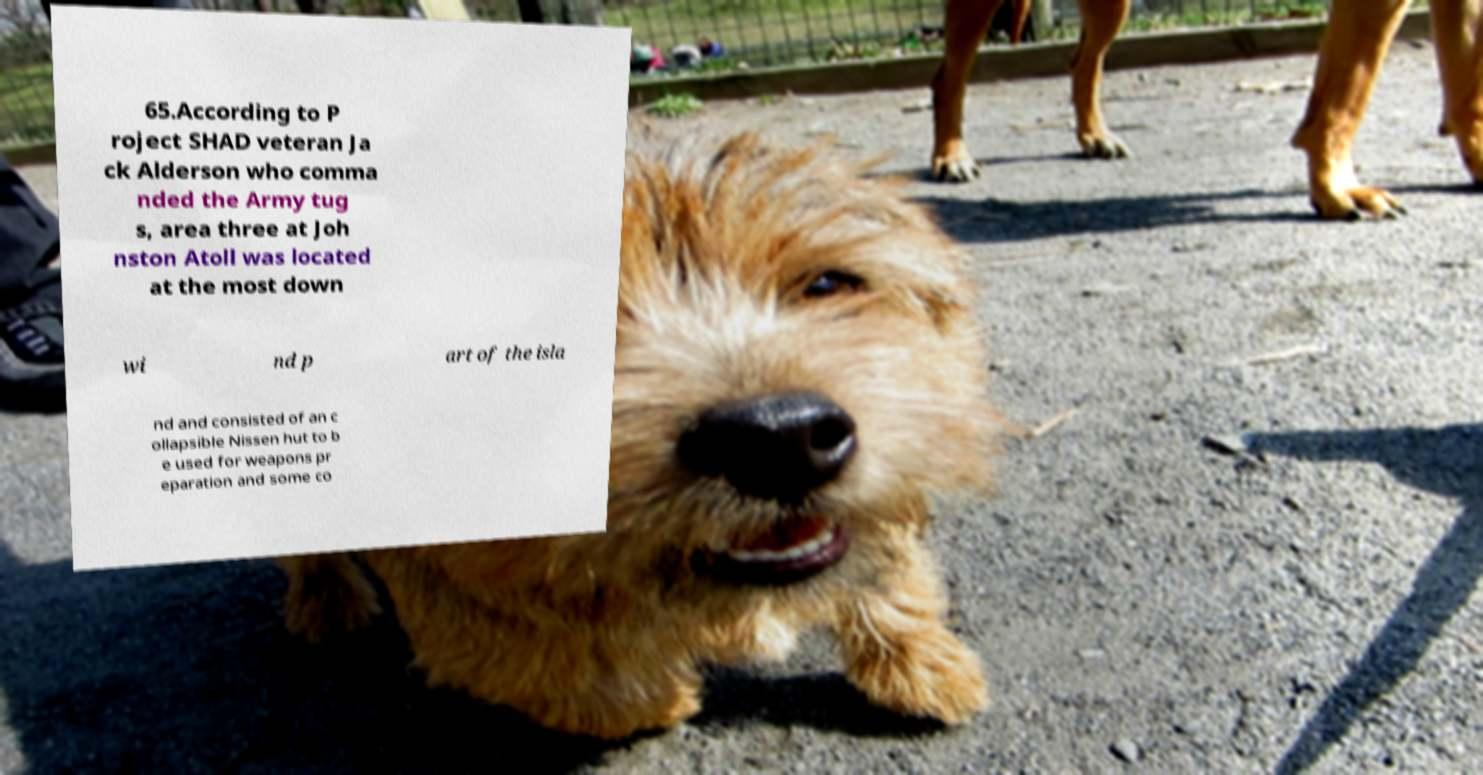Could you assist in decoding the text presented in this image and type it out clearly? 65.According to P roject SHAD veteran Ja ck Alderson who comma nded the Army tug s, area three at Joh nston Atoll was located at the most down wi nd p art of the isla nd and consisted of an c ollapsible Nissen hut to b e used for weapons pr eparation and some co 